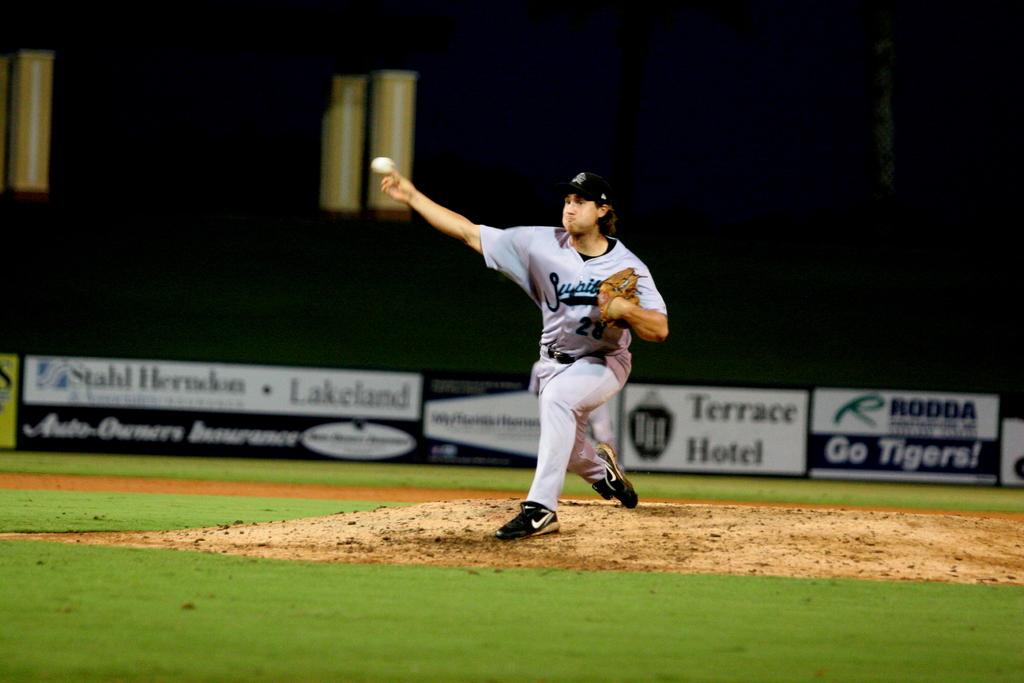What is the name of the hotel?
Your answer should be very brief. Terrace hotel. What team is the sign in the back right cheering for?
Ensure brevity in your answer.  Tigers. 